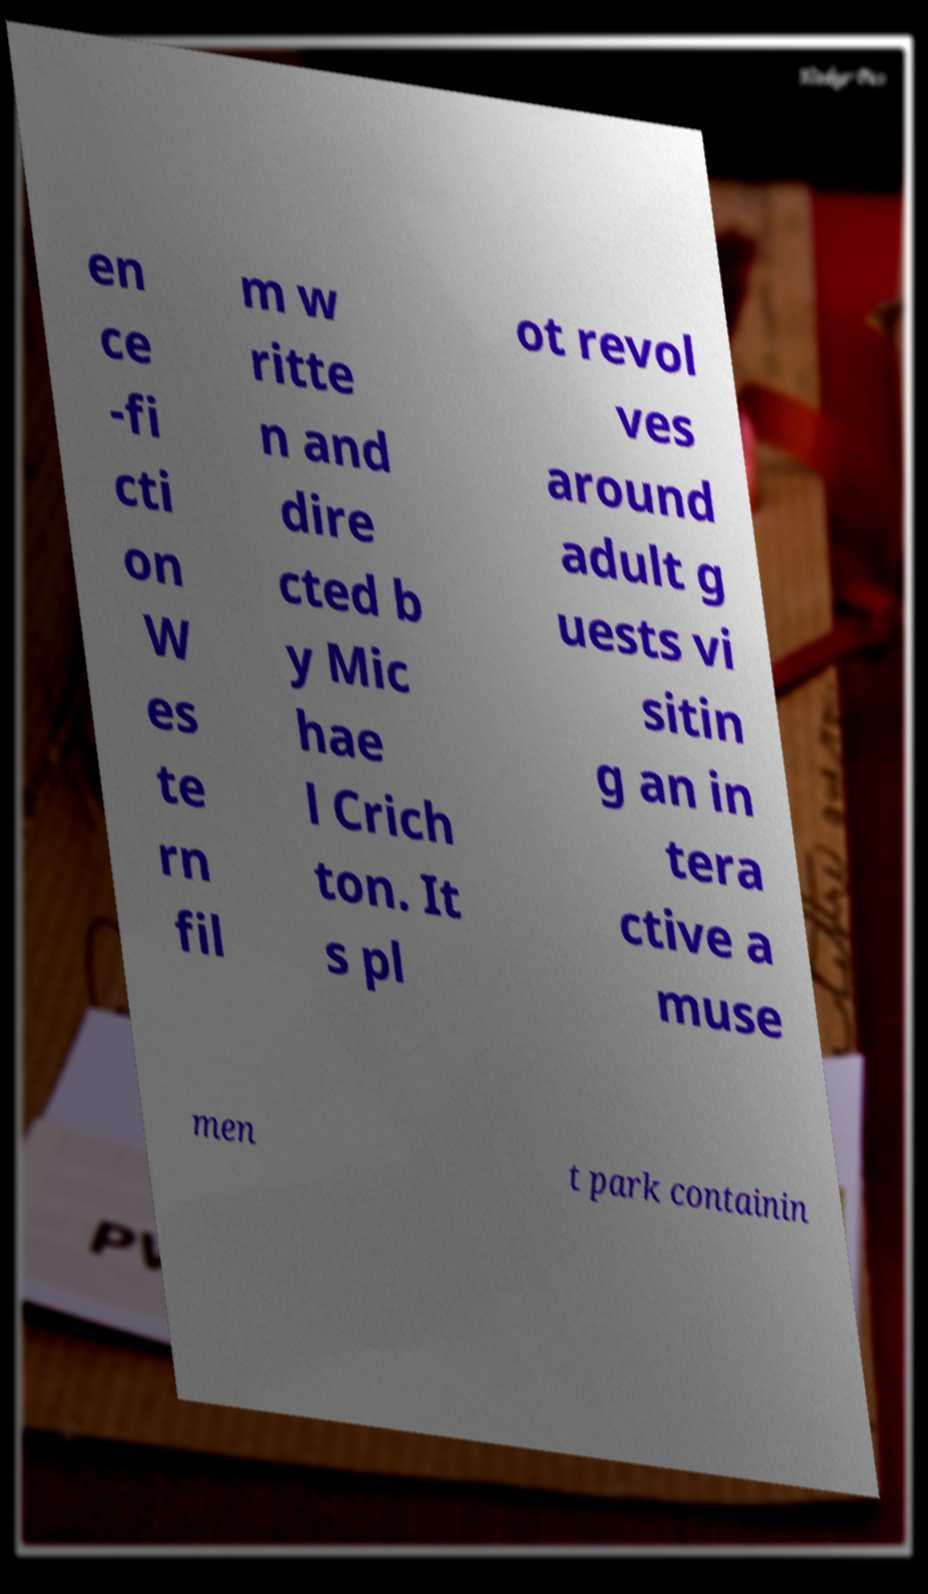What messages or text are displayed in this image? I need them in a readable, typed format. en ce -fi cti on W es te rn fil m w ritte n and dire cted b y Mic hae l Crich ton. It s pl ot revol ves around adult g uests vi sitin g an in tera ctive a muse men t park containin 